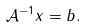Convert formula to latex. <formula><loc_0><loc_0><loc_500><loc_500>\mathcal { A } ^ { - 1 } { x } = { b } .</formula> 